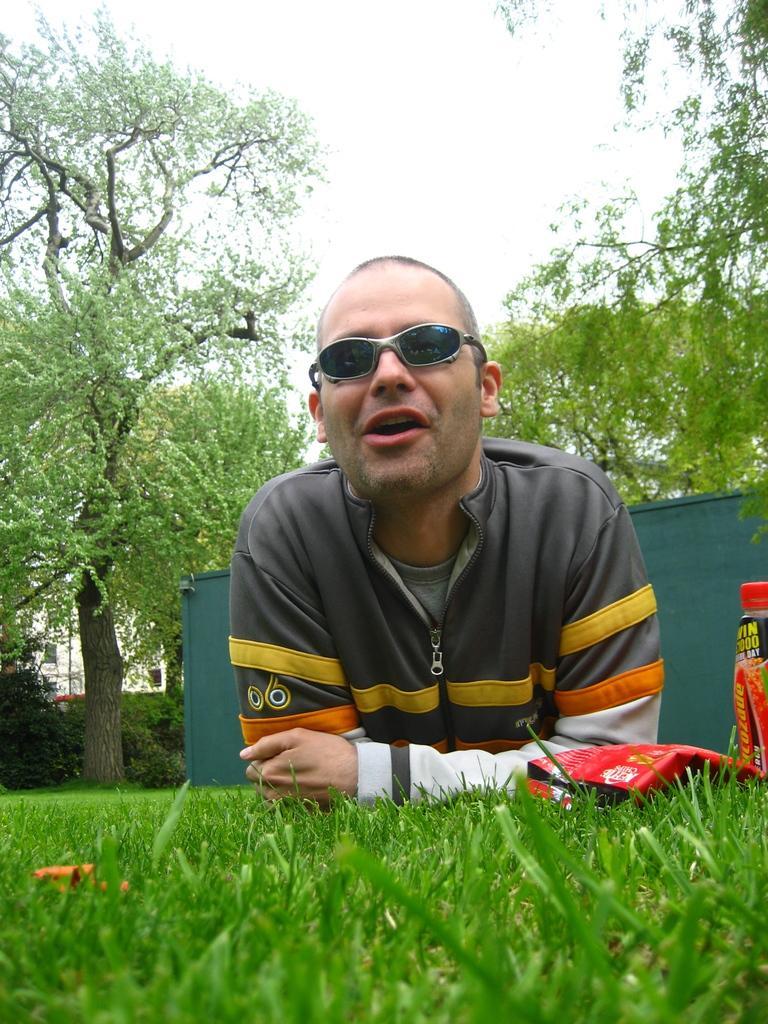In one or two sentences, can you explain what this image depicts? In this image in the center there is one person who is wearing goggles, beside him there is a packet and bottle. At the bottom there is grass, and in the background there is a container, trees, building. At the top there is sky. 